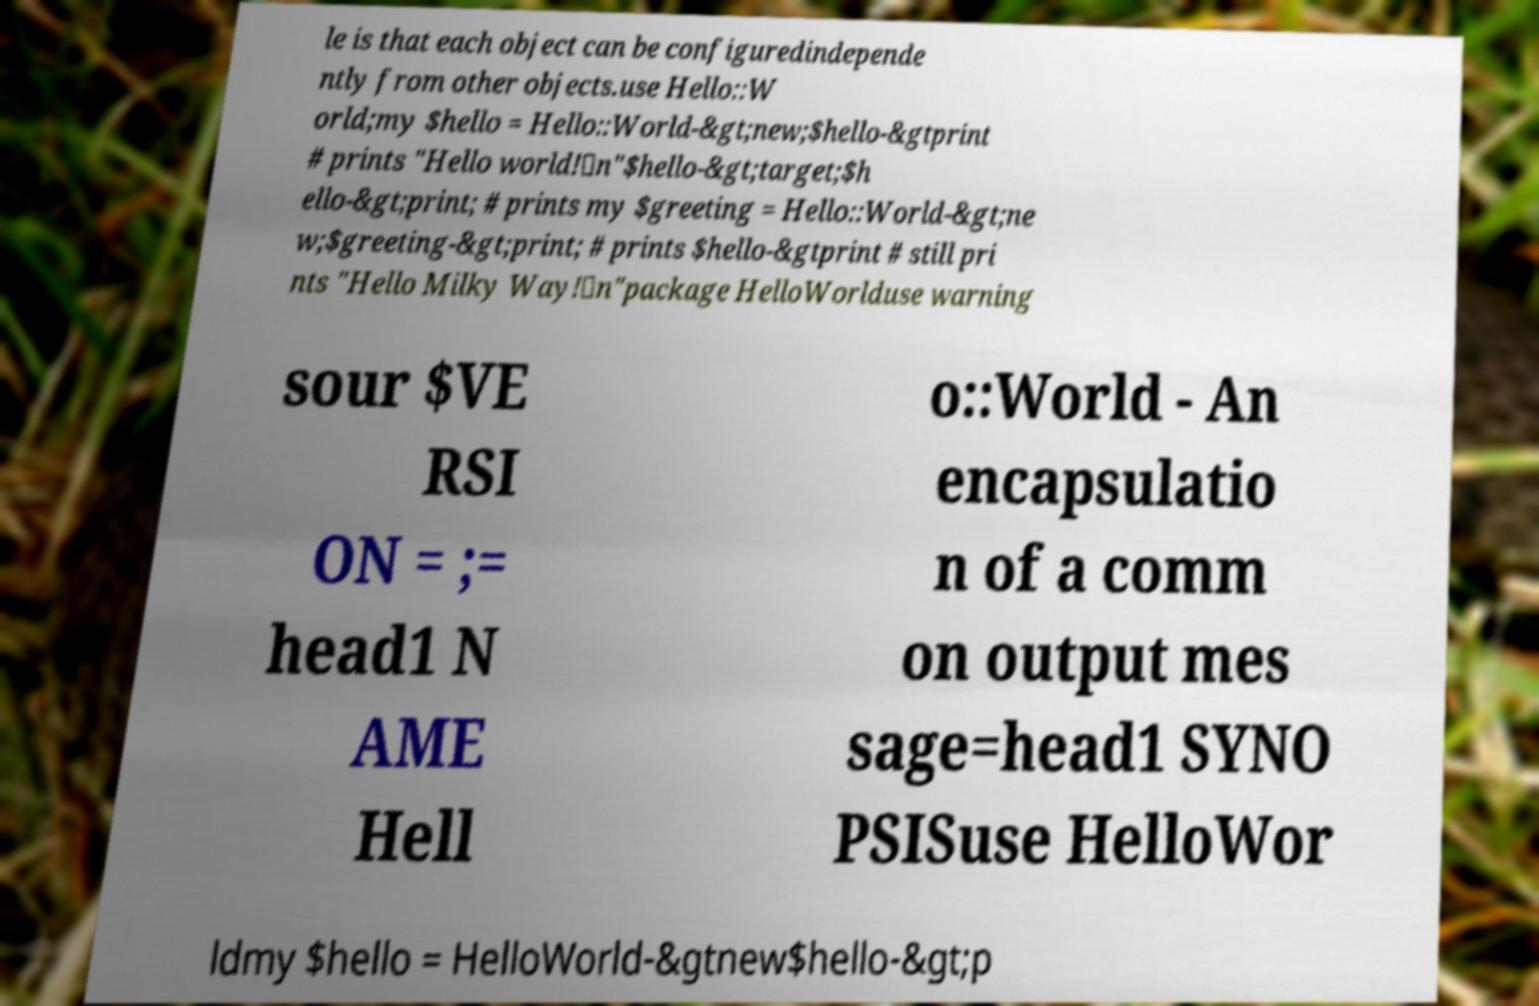Could you assist in decoding the text presented in this image and type it out clearly? le is that each object can be configuredindepende ntly from other objects.use Hello::W orld;my $hello = Hello::World-&gt;new;$hello-&gtprint # prints "Hello world!\n"$hello-&gt;target;$h ello-&gt;print; # prints my $greeting = Hello::World-&gt;ne w;$greeting-&gt;print; # prints $hello-&gtprint # still pri nts "Hello Milky Way!\n"package HelloWorlduse warning sour $VE RSI ON = ;= head1 N AME Hell o::World - An encapsulatio n of a comm on output mes sage=head1 SYNO PSISuse HelloWor ldmy $hello = HelloWorld-&gtnew$hello-&gt;p 